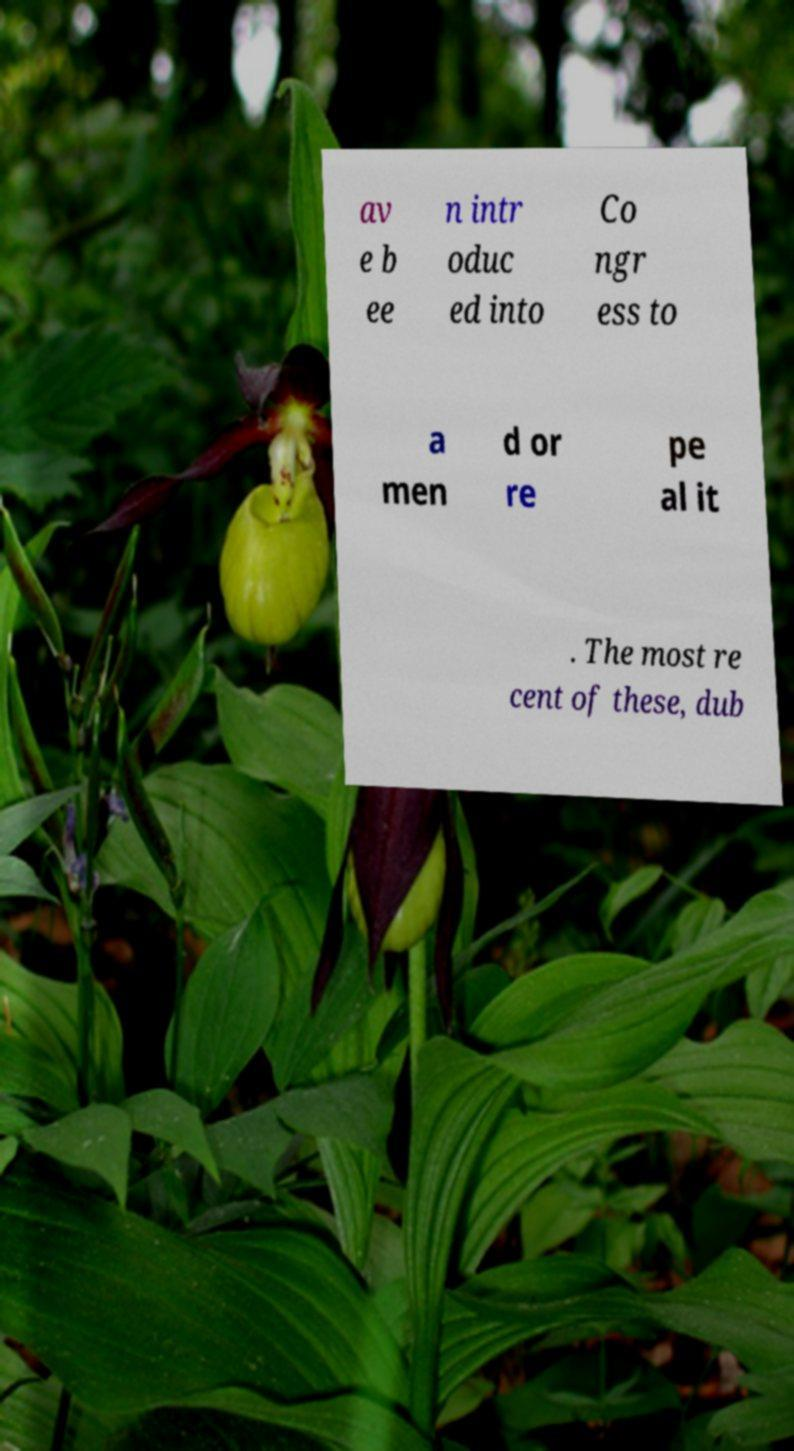Could you extract and type out the text from this image? av e b ee n intr oduc ed into Co ngr ess to a men d or re pe al it . The most re cent of these, dub 